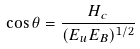<formula> <loc_0><loc_0><loc_500><loc_500>\cos \theta = \frac { H _ { c } } { ( E _ { u } E _ { B } ) ^ { 1 / 2 } }</formula> 